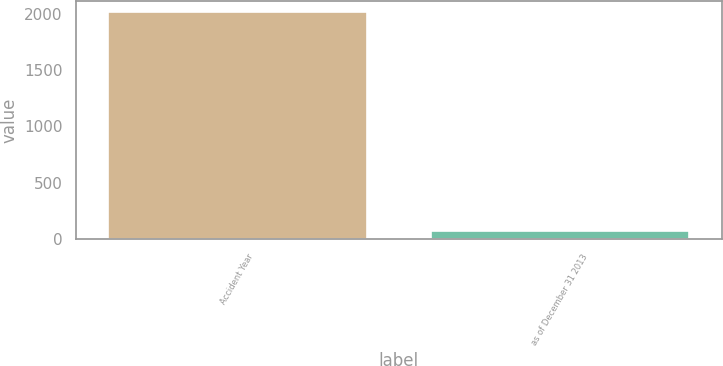<chart> <loc_0><loc_0><loc_500><loc_500><bar_chart><fcel>Accident Year<fcel>as of December 31 2013<nl><fcel>2011<fcel>68.6<nl></chart> 